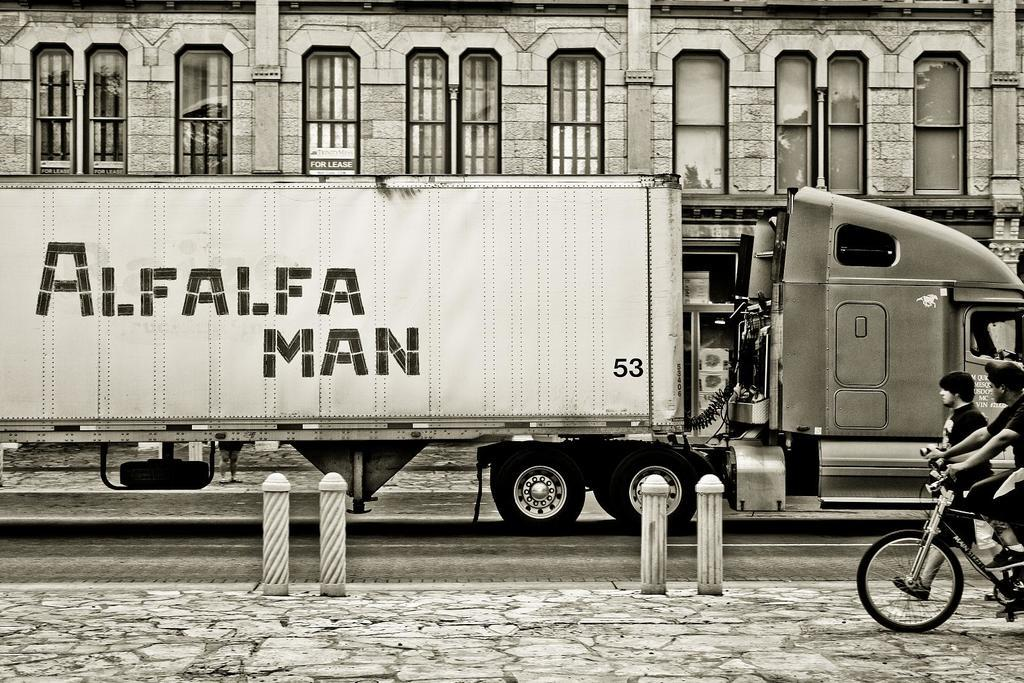What is the main subject of the image? The main subject of the image is a truck. What can be seen on the truck? There is writing on the truck. Are there any people visible in the image? Yes, there are two persons in the right corner of the image. What can be seen in the background of the image? There is a building in the background of the image. What type of quilt is being used to cover the dock in the image? There is no quilt or dock present in the image; it features a truck with writing and two persons in the right corner. 